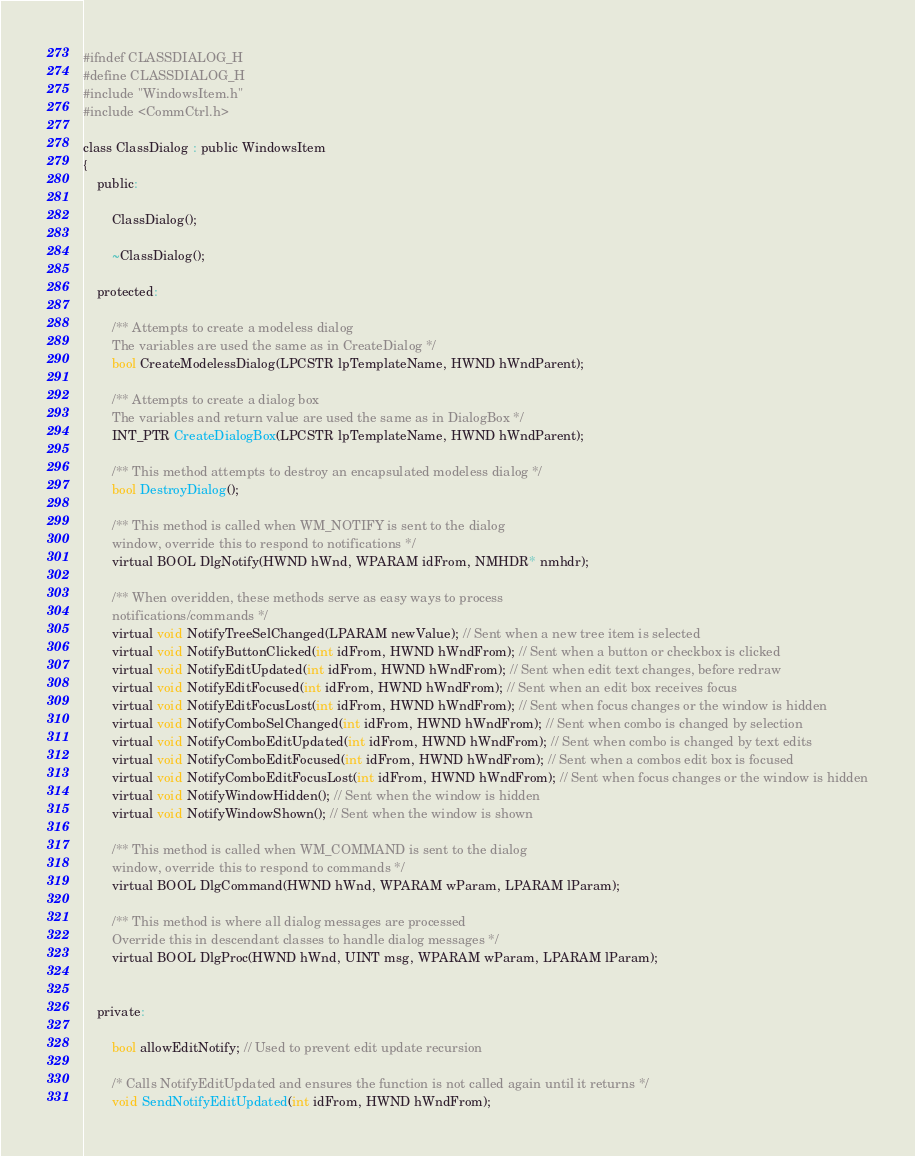<code> <loc_0><loc_0><loc_500><loc_500><_C_>#ifndef CLASSDIALOG_H
#define CLASSDIALOG_H
#include "WindowsItem.h"
#include <CommCtrl.h>

class ClassDialog : public WindowsItem
{
    public:

        ClassDialog();

        ~ClassDialog();

    protected:

        /** Attempts to create a modeless dialog
        The variables are used the same as in CreateDialog */
        bool CreateModelessDialog(LPCSTR lpTemplateName, HWND hWndParent);

        /** Attempts to create a dialog box
        The variables and return value are used the same as in DialogBox */
        INT_PTR CreateDialogBox(LPCSTR lpTemplateName, HWND hWndParent);

        /** This method attempts to destroy an encapsulated modeless dialog */
        bool DestroyDialog();

        /** This method is called when WM_NOTIFY is sent to the dialog
        window, override this to respond to notifications */
        virtual BOOL DlgNotify(HWND hWnd, WPARAM idFrom, NMHDR* nmhdr);

        /** When overidden, these methods serve as easy ways to process
        notifications/commands */
        virtual void NotifyTreeSelChanged(LPARAM newValue); // Sent when a new tree item is selected
        virtual void NotifyButtonClicked(int idFrom, HWND hWndFrom); // Sent when a button or checkbox is clicked
        virtual void NotifyEditUpdated(int idFrom, HWND hWndFrom); // Sent when edit text changes, before redraw
        virtual void NotifyEditFocused(int idFrom, HWND hWndFrom); // Sent when an edit box receives focus
        virtual void NotifyEditFocusLost(int idFrom, HWND hWndFrom); // Sent when focus changes or the window is hidden
        virtual void NotifyComboSelChanged(int idFrom, HWND hWndFrom); // Sent when combo is changed by selection
        virtual void NotifyComboEditUpdated(int idFrom, HWND hWndFrom); // Sent when combo is changed by text edits
        virtual void NotifyComboEditFocused(int idFrom, HWND hWndFrom); // Sent when a combos edit box is focused
        virtual void NotifyComboEditFocusLost(int idFrom, HWND hWndFrom); // Sent when focus changes or the window is hidden
        virtual void NotifyWindowHidden(); // Sent when the window is hidden
        virtual void NotifyWindowShown(); // Sent when the window is shown

        /** This method is called when WM_COMMAND is sent to the dialog
        window, override this to respond to commands */
        virtual BOOL DlgCommand(HWND hWnd, WPARAM wParam, LPARAM lParam);

        /** This method is where all dialog messages are processed
        Override this in descendant classes to handle dialog messages */
        virtual BOOL DlgProc(HWND hWnd, UINT msg, WPARAM wParam, LPARAM lParam);


    private:

        bool allowEditNotify; // Used to prevent edit update recursion

        /* Calls NotifyEditUpdated and ensures the function is not called again until it returns */
        void SendNotifyEditUpdated(int idFrom, HWND hWndFrom);
</code> 